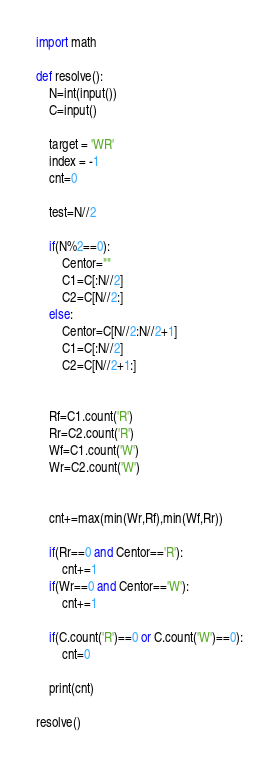<code> <loc_0><loc_0><loc_500><loc_500><_Python_>import math

def resolve():
    N=int(input())
    C=input()

    target = 'WR'
    index = -1
    cnt=0
    
    test=N//2

    if(N%2==0):
        Centor=""
        C1=C[:N//2]
        C2=C[N//2:]
    else:
        Centor=C[N//2:N//2+1]
        C1=C[:N//2]
        C2=C[N//2+1:]


    Rf=C1.count('R')
    Rr=C2.count('R')
    Wf=C1.count('W')
    Wr=C2.count('W')


    cnt+=max(min(Wr,Rf),min(Wf,Rr))

    if(Rr==0 and Centor=='R'):
        cnt+=1
    if(Wr==0 and Centor=='W'):
        cnt+=1

    if(C.count('R')==0 or C.count('W')==0):
        cnt=0

    print(cnt)
 
resolve()</code> 